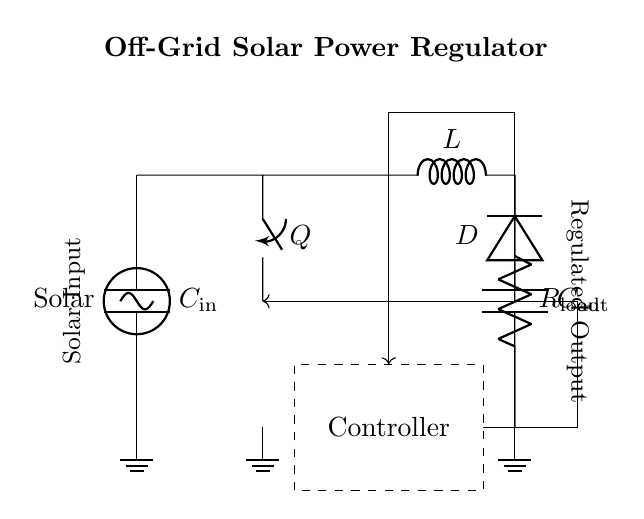What is the function of the solar panel in this circuit? The solar panel acts as the power source, converting solar energy into electrical energy to supply the circuit.
Answer: Power source What component is used for energy storage? The inductor stores energy temporarily during the switching operation of the regulator before it is released to the load.
Answer: Inductor How many capacitors are there in the circuit? There are two capacitors: one at the input (C_in) and one at the output (C_out), serving different functions in the regulation process.
Answer: Two What is the role of the diode in this circuit? The diode allows current to flow in one direction, preventing backflow from the output, which protects the circuit during the off time of the switch.
Answer: Prevent backflow How does the controller maintain the output voltage? The controller monitors the output voltage and adjusts the switching of the transistor to keep the output voltage regulated, according to the feedback received from the load.
Answer: Adjusts switching What is the likely output voltage regulation method used here? The circuit probably uses pulse-width modulation, modulating the switching time to control the amount of energy passed to the output, thus regulating the voltage level.
Answer: Pulse-width modulation 